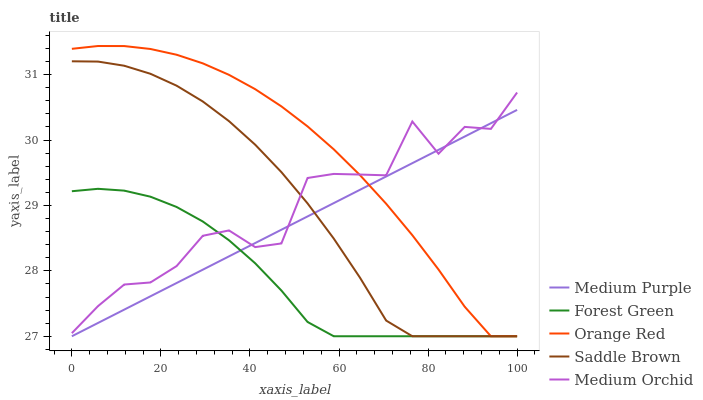Does Forest Green have the minimum area under the curve?
Answer yes or no. Yes. Does Orange Red have the maximum area under the curve?
Answer yes or no. Yes. Does Medium Orchid have the minimum area under the curve?
Answer yes or no. No. Does Medium Orchid have the maximum area under the curve?
Answer yes or no. No. Is Medium Purple the smoothest?
Answer yes or no. Yes. Is Medium Orchid the roughest?
Answer yes or no. Yes. Is Forest Green the smoothest?
Answer yes or no. No. Is Forest Green the roughest?
Answer yes or no. No. Does Medium Purple have the lowest value?
Answer yes or no. Yes. Does Medium Orchid have the lowest value?
Answer yes or no. No. Does Orange Red have the highest value?
Answer yes or no. Yes. Does Medium Orchid have the highest value?
Answer yes or no. No. Does Orange Red intersect Medium Orchid?
Answer yes or no. Yes. Is Orange Red less than Medium Orchid?
Answer yes or no. No. Is Orange Red greater than Medium Orchid?
Answer yes or no. No. 